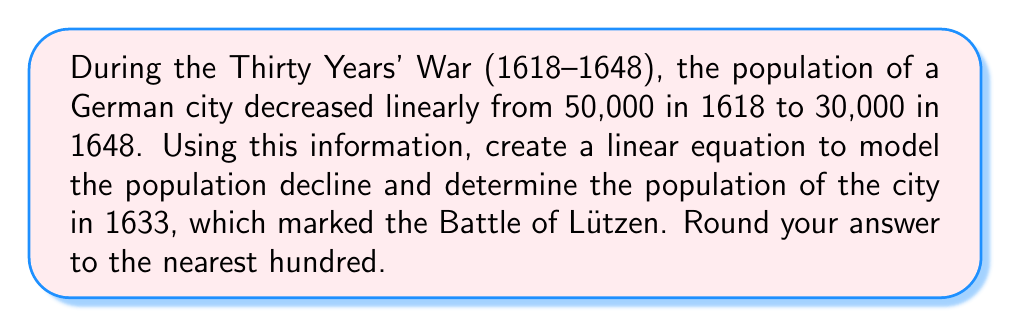Could you help me with this problem? Let's approach this step-by-step:

1) First, we need to create a linear equation in the form $y = mx + b$, where:
   $y$ is the population
   $x$ is the number of years since 1618
   $m$ is the slope (rate of population change per year)
   $b$ is the y-intercept (initial population in 1618)

2) We know two points:
   (0, 50000) for 1618
   (30, 30000) for 1648

3) Calculate the slope:
   $m = \frac{y_2 - y_1}{x_2 - x_1} = \frac{30000 - 50000}{30 - 0} = \frac{-20000}{30} = -666.67$

4) We can use the point (0, 50000) to find $b$:
   $50000 = -666.67(0) + b$
   $b = 50000$

5) Our linear equation is:
   $y = -666.67x + 50000$

6) To find the population in 1633, we need to calculate $x$:
   1633 - 1618 = 15 years

7) Plug $x = 15$ into our equation:
   $y = -666.67(15) + 50000$
   $y = -10000.05 + 50000$
   $y = 39999.95$

8) Rounding to the nearest hundred:
   $y \approx 40000$
Answer: 40,000 